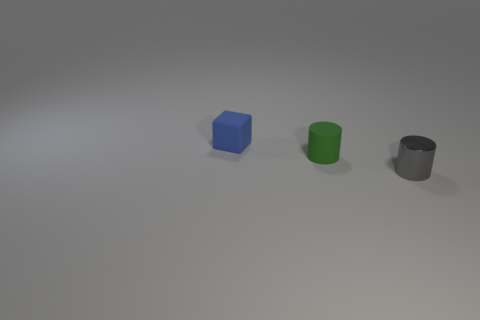Add 2 small gray metallic cylinders. How many objects exist? 5 Subtract all gray cylinders. How many cylinders are left? 1 Subtract all cubes. How many objects are left? 2 Subtract 1 blocks. How many blocks are left? 0 Subtract all small brown shiny things. Subtract all tiny cylinders. How many objects are left? 1 Add 1 small matte cubes. How many small matte cubes are left? 2 Add 3 large gray cylinders. How many large gray cylinders exist? 3 Subtract 1 blue blocks. How many objects are left? 2 Subtract all brown cylinders. Subtract all yellow blocks. How many cylinders are left? 2 